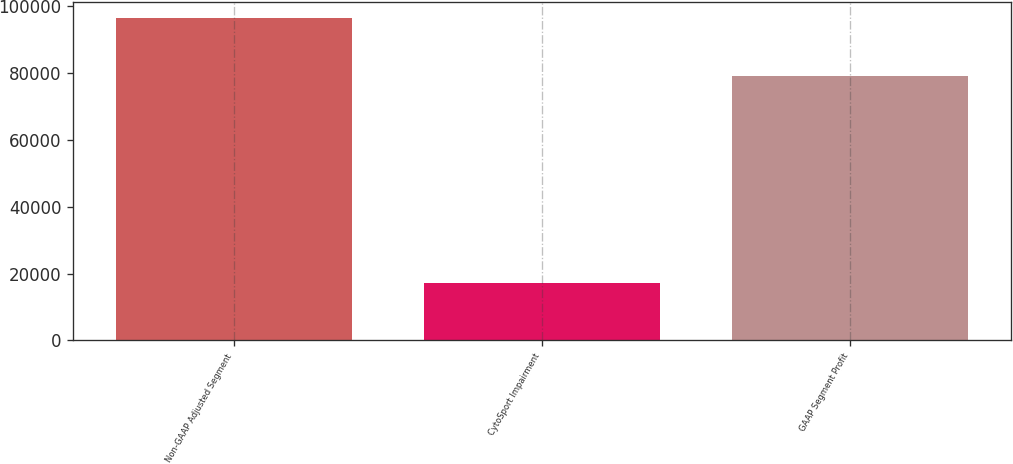Convert chart to OTSL. <chart><loc_0><loc_0><loc_500><loc_500><bar_chart><fcel>Non-GAAP Adjusted Segment<fcel>CytoSport Impairment<fcel>GAAP Segment Profit<nl><fcel>96361<fcel>17279<fcel>79082<nl></chart> 